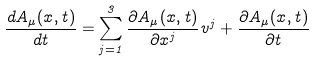Convert formula to latex. <formula><loc_0><loc_0><loc_500><loc_500>\frac { d A _ { \mu } ( { x } , t ) } { d t } = \sum _ { j = 1 } ^ { 3 } \frac { \partial A _ { \mu } ( { x } , t ) } { \partial x ^ { j } } v ^ { j } + \frac { \partial A _ { \mu } ( { x } , t ) } { \partial t }</formula> 